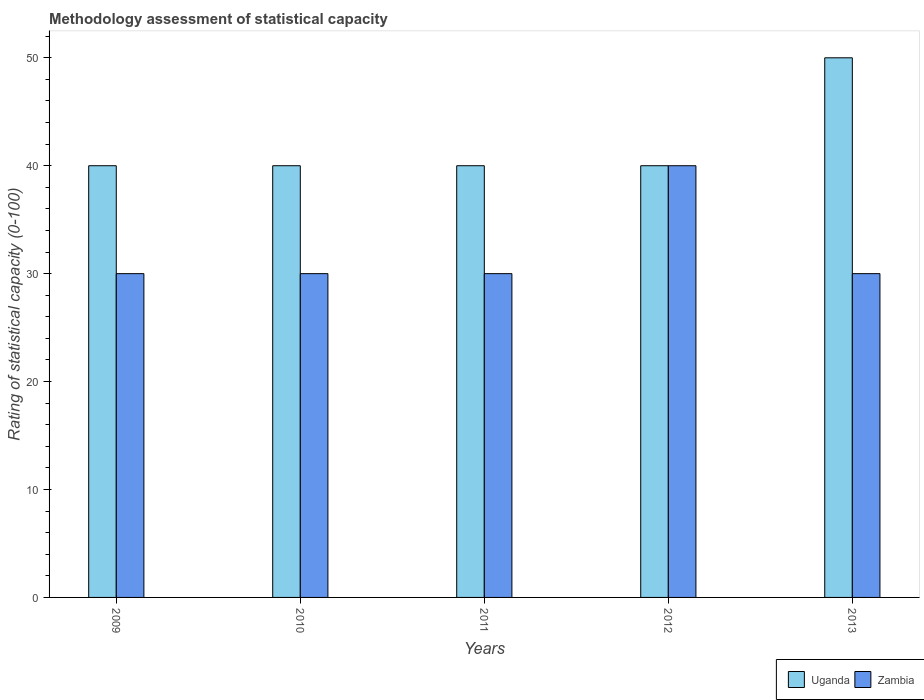Are the number of bars per tick equal to the number of legend labels?
Your answer should be very brief. Yes. How many bars are there on the 4th tick from the right?
Your answer should be very brief. 2. What is the label of the 4th group of bars from the left?
Make the answer very short. 2012. In how many cases, is the number of bars for a given year not equal to the number of legend labels?
Make the answer very short. 0. What is the rating of statistical capacity in Uganda in 2012?
Ensure brevity in your answer.  40. Across all years, what is the maximum rating of statistical capacity in Uganda?
Give a very brief answer. 50. Across all years, what is the minimum rating of statistical capacity in Zambia?
Offer a very short reply. 30. In which year was the rating of statistical capacity in Uganda minimum?
Your response must be concise. 2009. What is the total rating of statistical capacity in Zambia in the graph?
Provide a succinct answer. 160. In the year 2011, what is the difference between the rating of statistical capacity in Zambia and rating of statistical capacity in Uganda?
Provide a succinct answer. -10. In how many years, is the rating of statistical capacity in Zambia greater than 38?
Make the answer very short. 1. What is the ratio of the rating of statistical capacity in Zambia in 2009 to that in 2012?
Your response must be concise. 0.75. Is the difference between the rating of statistical capacity in Zambia in 2010 and 2013 greater than the difference between the rating of statistical capacity in Uganda in 2010 and 2013?
Your answer should be very brief. Yes. What is the difference between the highest and the lowest rating of statistical capacity in Zambia?
Offer a very short reply. 10. In how many years, is the rating of statistical capacity in Zambia greater than the average rating of statistical capacity in Zambia taken over all years?
Make the answer very short. 1. What does the 1st bar from the left in 2012 represents?
Your answer should be very brief. Uganda. What does the 2nd bar from the right in 2013 represents?
Make the answer very short. Uganda. Are all the bars in the graph horizontal?
Keep it short and to the point. No. How many years are there in the graph?
Your answer should be very brief. 5. Where does the legend appear in the graph?
Provide a succinct answer. Bottom right. How many legend labels are there?
Give a very brief answer. 2. How are the legend labels stacked?
Provide a succinct answer. Horizontal. What is the title of the graph?
Give a very brief answer. Methodology assessment of statistical capacity. Does "Cote d'Ivoire" appear as one of the legend labels in the graph?
Provide a succinct answer. No. What is the label or title of the Y-axis?
Your answer should be compact. Rating of statistical capacity (0-100). What is the Rating of statistical capacity (0-100) of Zambia in 2009?
Provide a succinct answer. 30. What is the Rating of statistical capacity (0-100) of Zambia in 2012?
Offer a very short reply. 40. What is the Rating of statistical capacity (0-100) of Zambia in 2013?
Offer a very short reply. 30. Across all years, what is the maximum Rating of statistical capacity (0-100) of Uganda?
Make the answer very short. 50. Across all years, what is the maximum Rating of statistical capacity (0-100) of Zambia?
Offer a terse response. 40. What is the total Rating of statistical capacity (0-100) of Uganda in the graph?
Ensure brevity in your answer.  210. What is the total Rating of statistical capacity (0-100) of Zambia in the graph?
Offer a terse response. 160. What is the difference between the Rating of statistical capacity (0-100) in Uganda in 2009 and that in 2010?
Provide a succinct answer. 0. What is the difference between the Rating of statistical capacity (0-100) of Zambia in 2009 and that in 2011?
Offer a very short reply. 0. What is the difference between the Rating of statistical capacity (0-100) of Uganda in 2009 and that in 2012?
Provide a short and direct response. 0. What is the difference between the Rating of statistical capacity (0-100) in Uganda in 2009 and that in 2013?
Keep it short and to the point. -10. What is the difference between the Rating of statistical capacity (0-100) in Zambia in 2009 and that in 2013?
Make the answer very short. 0. What is the difference between the Rating of statistical capacity (0-100) of Zambia in 2010 and that in 2012?
Make the answer very short. -10. What is the difference between the Rating of statistical capacity (0-100) of Uganda in 2010 and that in 2013?
Your response must be concise. -10. What is the difference between the Rating of statistical capacity (0-100) in Zambia in 2010 and that in 2013?
Your answer should be compact. 0. What is the difference between the Rating of statistical capacity (0-100) in Zambia in 2011 and that in 2012?
Make the answer very short. -10. What is the difference between the Rating of statistical capacity (0-100) in Uganda in 2011 and that in 2013?
Provide a succinct answer. -10. What is the difference between the Rating of statistical capacity (0-100) of Zambia in 2011 and that in 2013?
Your answer should be very brief. 0. What is the difference between the Rating of statistical capacity (0-100) of Uganda in 2012 and that in 2013?
Provide a short and direct response. -10. What is the difference between the Rating of statistical capacity (0-100) of Zambia in 2012 and that in 2013?
Provide a succinct answer. 10. What is the difference between the Rating of statistical capacity (0-100) of Uganda in 2010 and the Rating of statistical capacity (0-100) of Zambia in 2011?
Your response must be concise. 10. What is the difference between the Rating of statistical capacity (0-100) of Uganda in 2010 and the Rating of statistical capacity (0-100) of Zambia in 2012?
Provide a short and direct response. 0. What is the difference between the Rating of statistical capacity (0-100) in Uganda in 2010 and the Rating of statistical capacity (0-100) in Zambia in 2013?
Provide a succinct answer. 10. What is the difference between the Rating of statistical capacity (0-100) of Uganda in 2012 and the Rating of statistical capacity (0-100) of Zambia in 2013?
Provide a short and direct response. 10. What is the average Rating of statistical capacity (0-100) in Uganda per year?
Ensure brevity in your answer.  42. In the year 2009, what is the difference between the Rating of statistical capacity (0-100) in Uganda and Rating of statistical capacity (0-100) in Zambia?
Ensure brevity in your answer.  10. In the year 2010, what is the difference between the Rating of statistical capacity (0-100) in Uganda and Rating of statistical capacity (0-100) in Zambia?
Keep it short and to the point. 10. In the year 2011, what is the difference between the Rating of statistical capacity (0-100) in Uganda and Rating of statistical capacity (0-100) in Zambia?
Your answer should be compact. 10. In the year 2013, what is the difference between the Rating of statistical capacity (0-100) of Uganda and Rating of statistical capacity (0-100) of Zambia?
Ensure brevity in your answer.  20. What is the ratio of the Rating of statistical capacity (0-100) of Uganda in 2009 to that in 2010?
Provide a succinct answer. 1. What is the ratio of the Rating of statistical capacity (0-100) of Zambia in 2009 to that in 2010?
Make the answer very short. 1. What is the ratio of the Rating of statistical capacity (0-100) in Uganda in 2009 to that in 2011?
Give a very brief answer. 1. What is the ratio of the Rating of statistical capacity (0-100) in Zambia in 2009 to that in 2012?
Make the answer very short. 0.75. What is the ratio of the Rating of statistical capacity (0-100) of Uganda in 2010 to that in 2011?
Give a very brief answer. 1. What is the ratio of the Rating of statistical capacity (0-100) of Zambia in 2010 to that in 2011?
Keep it short and to the point. 1. What is the ratio of the Rating of statistical capacity (0-100) of Zambia in 2010 to that in 2012?
Offer a very short reply. 0.75. What is the ratio of the Rating of statistical capacity (0-100) in Uganda in 2010 to that in 2013?
Your answer should be very brief. 0.8. What is the ratio of the Rating of statistical capacity (0-100) of Zambia in 2010 to that in 2013?
Make the answer very short. 1. What is the ratio of the Rating of statistical capacity (0-100) in Zambia in 2011 to that in 2012?
Your response must be concise. 0.75. What is the ratio of the Rating of statistical capacity (0-100) in Uganda in 2011 to that in 2013?
Make the answer very short. 0.8. What is the difference between the highest and the second highest Rating of statistical capacity (0-100) in Uganda?
Your answer should be compact. 10. What is the difference between the highest and the second highest Rating of statistical capacity (0-100) of Zambia?
Keep it short and to the point. 10. What is the difference between the highest and the lowest Rating of statistical capacity (0-100) in Uganda?
Offer a terse response. 10. 